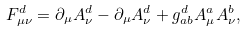<formula> <loc_0><loc_0><loc_500><loc_500>F ^ { d } _ { \mu \nu } = \partial _ { \mu } A ^ { d } _ { \nu } - \partial _ { \mu } A ^ { d } _ { \nu } + g ^ { d } _ { a b } A ^ { a } _ { \mu } A ^ { b } _ { \nu } ,</formula> 